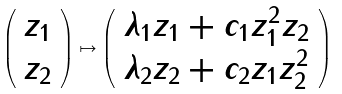<formula> <loc_0><loc_0><loc_500><loc_500>\left ( \begin{array} { l } z _ { 1 } \\ z _ { 2 } \end{array} \right ) \mapsto \left ( \begin{array} { l } \lambda _ { 1 } z _ { 1 } + c _ { 1 } z _ { 1 } ^ { 2 } z _ { 2 } \\ \lambda _ { 2 } z _ { 2 } + c _ { 2 } z _ { 1 } z _ { 2 } ^ { 2 } \\ \end{array} \right )</formula> 